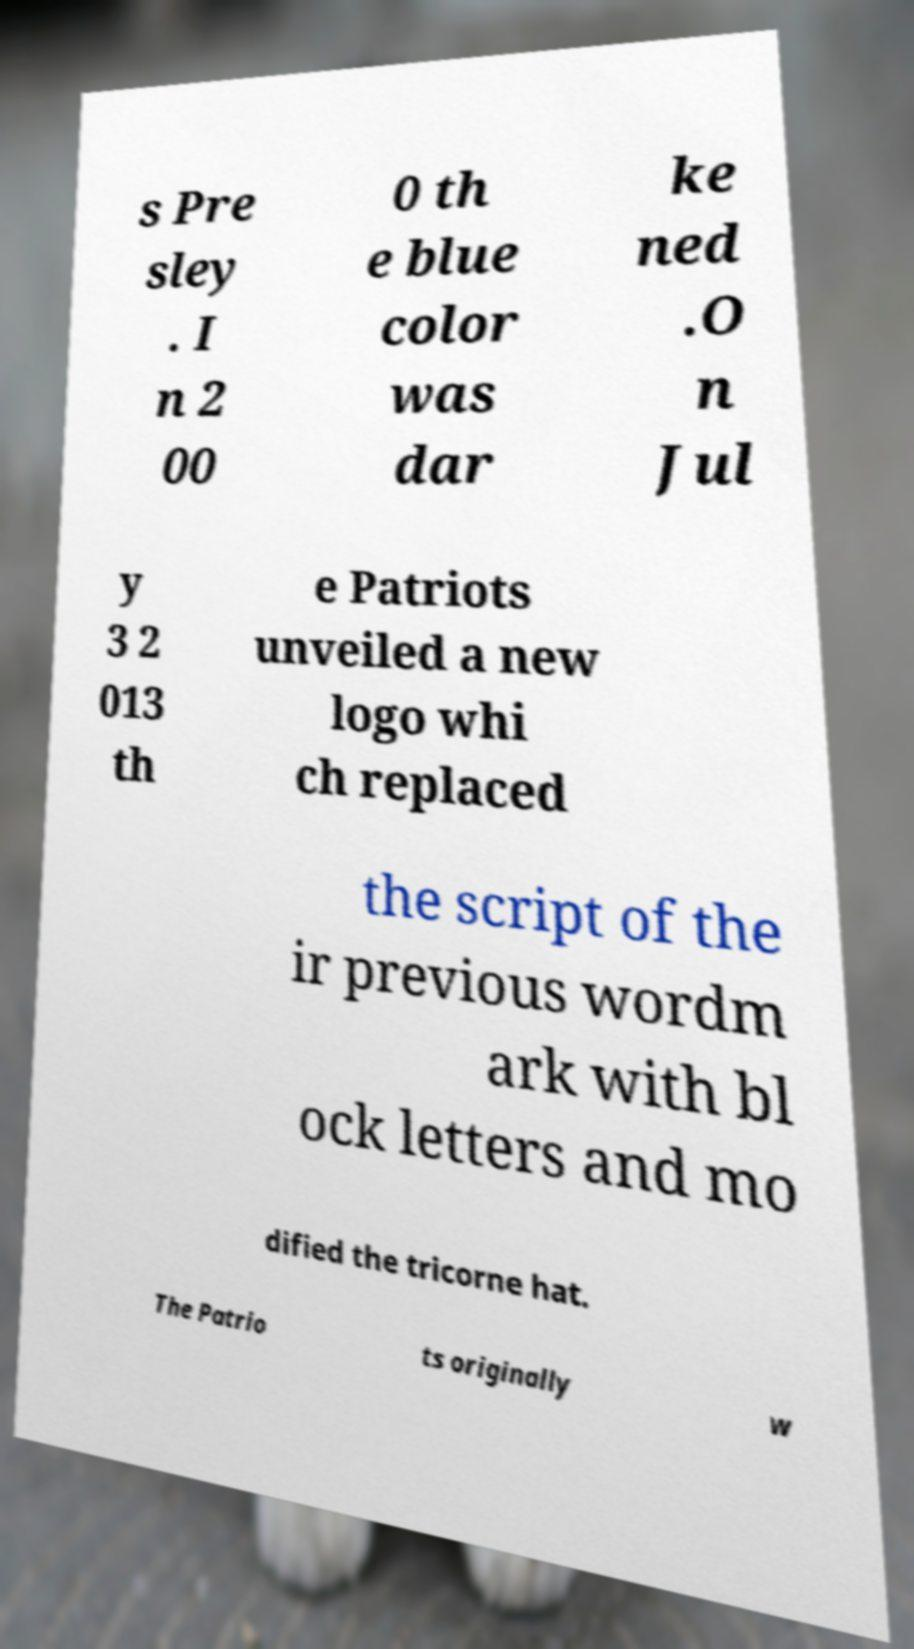For documentation purposes, I need the text within this image transcribed. Could you provide that? s Pre sley . I n 2 00 0 th e blue color was dar ke ned .O n Jul y 3 2 013 th e Patriots unveiled a new logo whi ch replaced the script of the ir previous wordm ark with bl ock letters and mo dified the tricorne hat. The Patrio ts originally w 